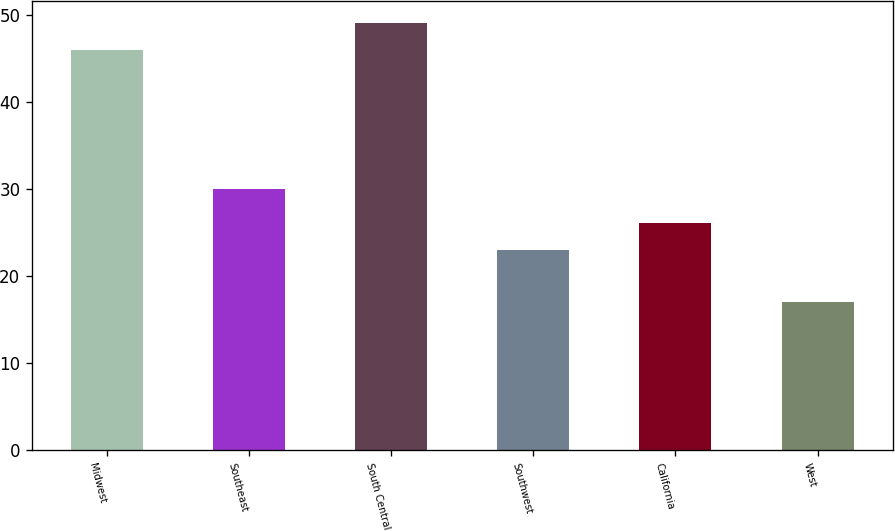<chart> <loc_0><loc_0><loc_500><loc_500><bar_chart><fcel>Midwest<fcel>Southeast<fcel>South Central<fcel>Southwest<fcel>California<fcel>West<nl><fcel>46<fcel>30<fcel>49.1<fcel>23<fcel>26.1<fcel>17<nl></chart> 